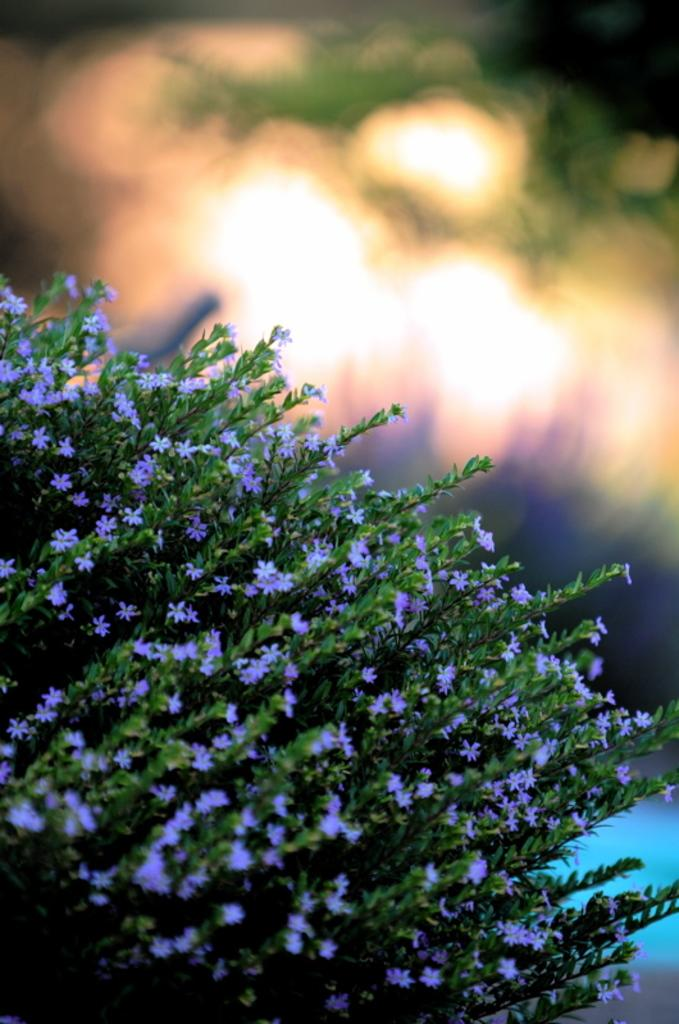What type of plants are featured in the picture? There are flowering plants in the picture. Can you describe the background of the flowering plants? The background of the flowering plants is blurred. What type of family heirloom can be seen hanging from the flowering plants in the image? There is no family heirloom, such as a locket, present in the image. What type of wind, like a gentle breeze, can be seen blowing through the flowering plants in the image? There is no wind, such as a zephyr, depicted in the image. 